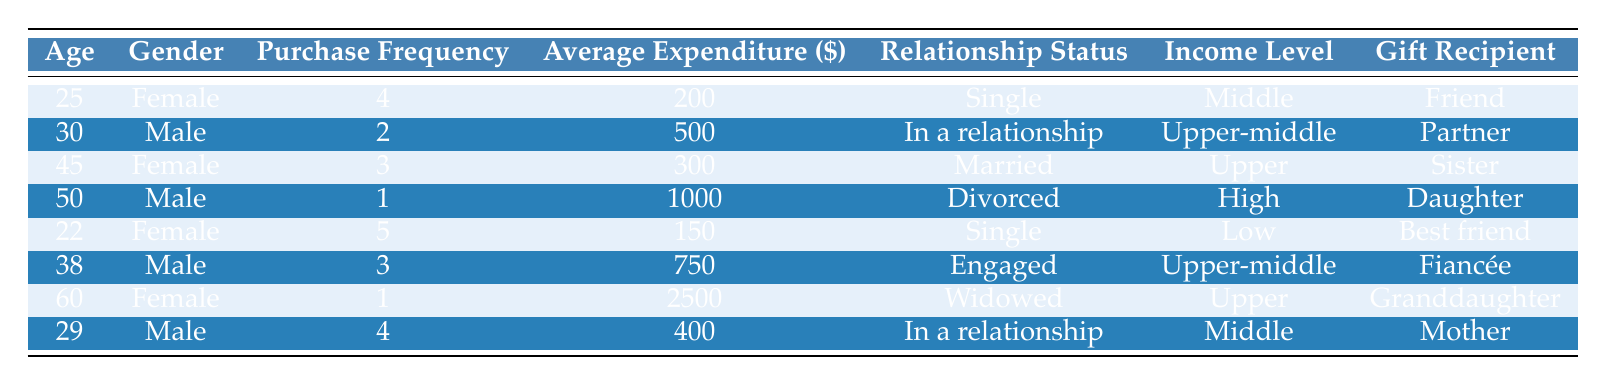What is the average expenditure of individuals who purchase jewelry as gifts? To find the average expenditure, sum the average expenditures of all individuals: 200 + 500 + 300 + 1000 + 150 + 750 + 2500 + 400 = 4750. There are 8 individuals, so the average is 4750 / 8 = 593.75
Answer: 593.75 How many individuals are engaged at the time of purchasing jewelry? There is one individual listed as engaged, which is the male aged 38, who has a purchase frequency of 3 and an average expenditure of 750.
Answer: 1 Which gender has a higher frequency of jewelry purchases based on the data provided? The females are 25, 45, and 22 and have purchase frequencies of 4, 3, and 5 respectively, with a total frequency of 12. The males are 30, 50, 38, and 29 with frequencies of 2, 1, 3, and 4 respectively, totaling 10. Therefore, females have a higher frequency.
Answer: Females Is there any individual who spends more than $1500 on average when purchasing gifts? Yes, the individual who is 60 years old and female has an average expenditure of 2500, which is greater than 1500.
Answer: Yes What is the total purchase frequency of males listed in the table? The purchase frequencies for males are: 2 (aged 30) + 1 (aged 50) + 3 (aged 38) + 4 (aged 29) = 10. Therefore, the total purchase frequency of males is 10.
Answer: 10 Among the individuals listed, who has the highest average expenditure, and what is that amount? The individual with the highest average expenditure is the 60-year-old female, who spends 2500 on average when purchasing gifts.
Answer: 2500 Are there any individuals who are single and spend at least $200 on average for jewelry gifts? Yes, there are two individuals who are single (aged 25 and 22). The 25-year-old female spends 200, and the 22-year-old spends 150. Only the 25-year-old meets the criteria of spending at least 200.
Answer: Yes What is the median average expenditure of individuals purchasing gifts according to their data? To find the median, first arrange the average expenditures in order: 150, 200, 300, 400, 500, 750, 1000, 2500. There are 8 values; thus, the median is the average of the 4th and 5th values: (400 + 500) / 2 = 450.
Answer: 450 